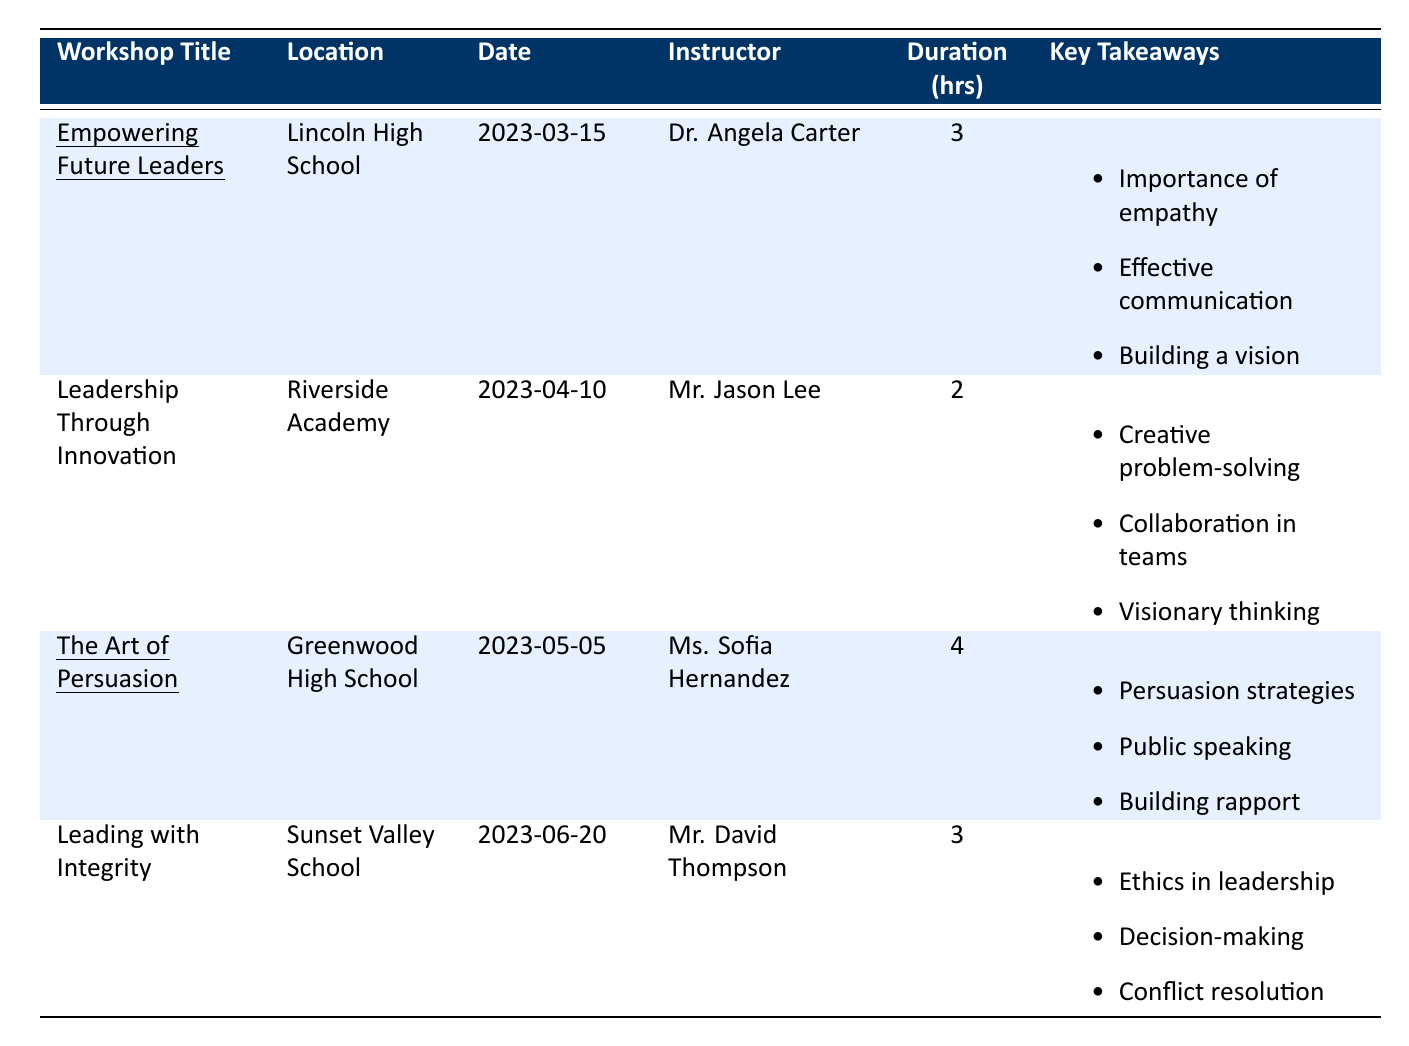What is the overall satisfaction rating for the workshop "Empowering Future Leaders"? The table indicates that the overall satisfaction for this workshop is 4.8.
Answer: 4.8 Who was the instructor for "The Art of Persuasion"? The table lists Ms. Sofia Hernandez as the instructor for "The Art of Persuasion".
Answer: Ms. Sofia Hernandez Which workshop had the longest duration? "The Art of Persuasion" lasted for 4 hours, which is longer than the others (3 hours or 2 hours).
Answer: The Art of Persuasion What are two key takeaways from the workshop "Leadership Through Innovation"? From the table, two key takeaways are "Creative problem-solving techniques" and "Collaboration in teams".
Answer: Creative problem-solving techniques, Collaboration in teams Which workshop had the lowest overall satisfaction rating? The overall satisfaction ratings are 4.8, 4.5, 4.9, and 4.7 for the workshops. "Leadership Through Innovation" has the lowest rating at 4.5.
Answer: Leadership Through Innovation What is the average overall satisfaction rating for all workshops? To find the average, add the ratings: 4.8 + 4.5 + 4.9 + 4.7 = 19.9, then divide by 4 (the number of workshops): 19.9 / 4 = 4.975.
Answer: 4.975 Do all workshops recommend improvements? Yes, each workshop has a suggestion for improvement listed in the student feedback.
Answer: Yes How many workshops did Dr. Angela Carter conduct, and what was her overall satisfaction rating? Dr. Angela Carter conducted one workshop, "Empowering Future Leaders," which has an overall satisfaction rating of 4.8.
Answer: 1 workshop, 4.8 What is the total number of hours for all workshops combined? Add the durations: 3 + 2 + 4 + 3 = 12 hours total for all workshops.
Answer: 12 hours Which two workshops emphasized skills related to ethics and integrity? The workshops "Leading with Integrity" emphasized ethics, while "Empowering Future Leaders" highlighted empathy, which is related to integrity.
Answer: Leading with Integrity, Empowering Future Leaders 